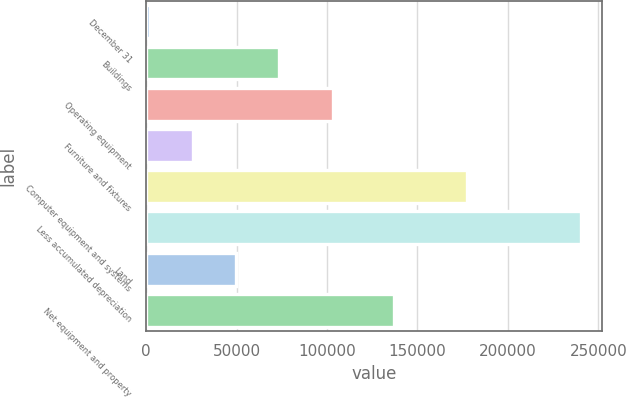Convert chart. <chart><loc_0><loc_0><loc_500><loc_500><bar_chart><fcel>December 31<fcel>Buildings<fcel>Operating equipment<fcel>Furniture and fixtures<fcel>Computer equipment and systems<fcel>Less accumulated depreciation<fcel>Land<fcel>Net equipment and property<nl><fcel>2018<fcel>73508.6<fcel>103429<fcel>25848.2<fcel>177441<fcel>240320<fcel>49678.4<fcel>136885<nl></chart> 